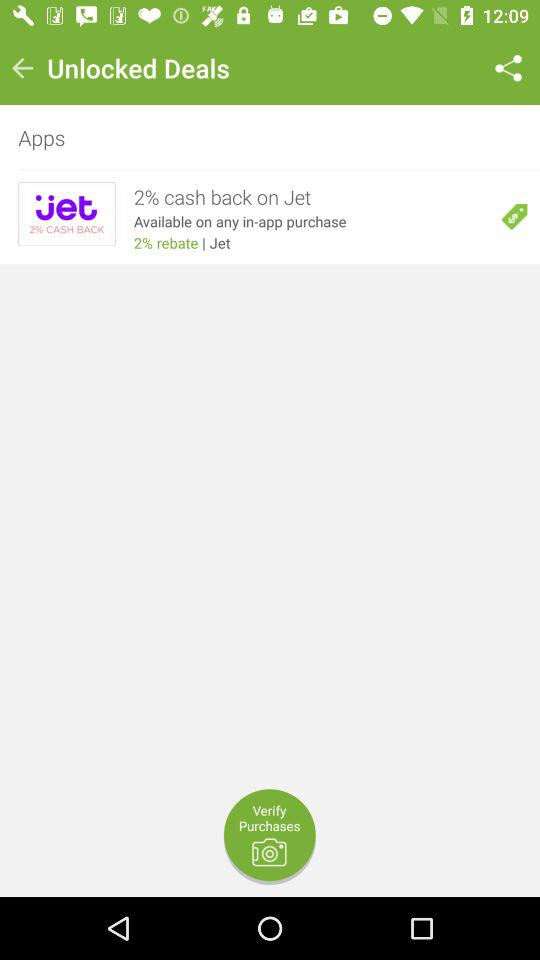Which app is the cashback available on? The cashback is available on "Jet". 